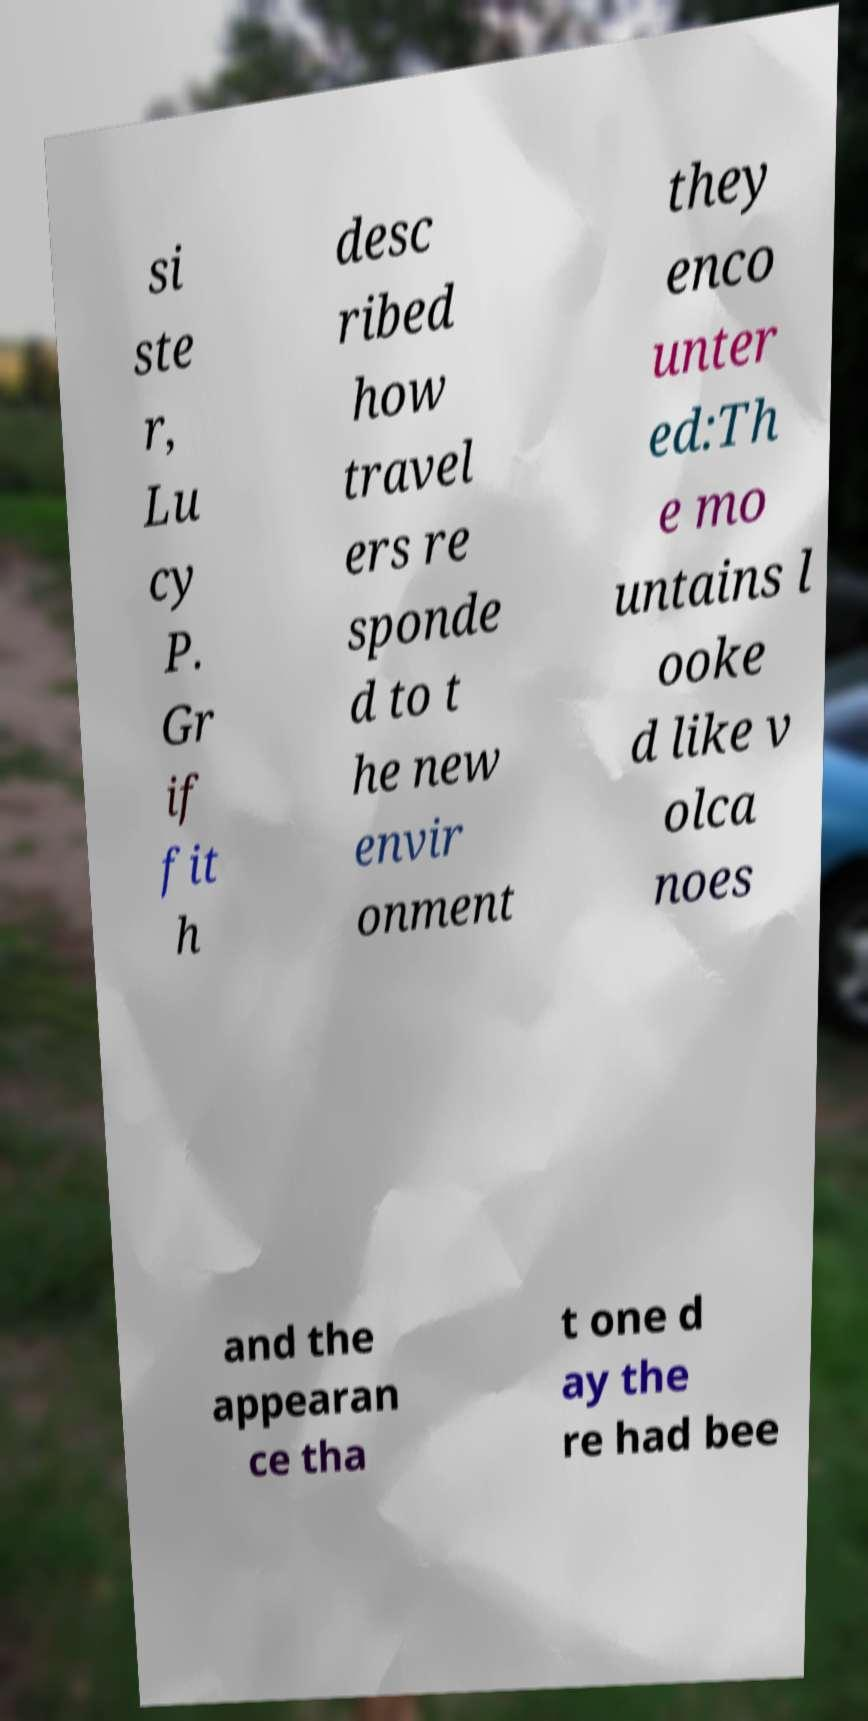Please read and relay the text visible in this image. What does it say? si ste r, Lu cy P. Gr if fit h desc ribed how travel ers re sponde d to t he new envir onment they enco unter ed:Th e mo untains l ooke d like v olca noes and the appearan ce tha t one d ay the re had bee 